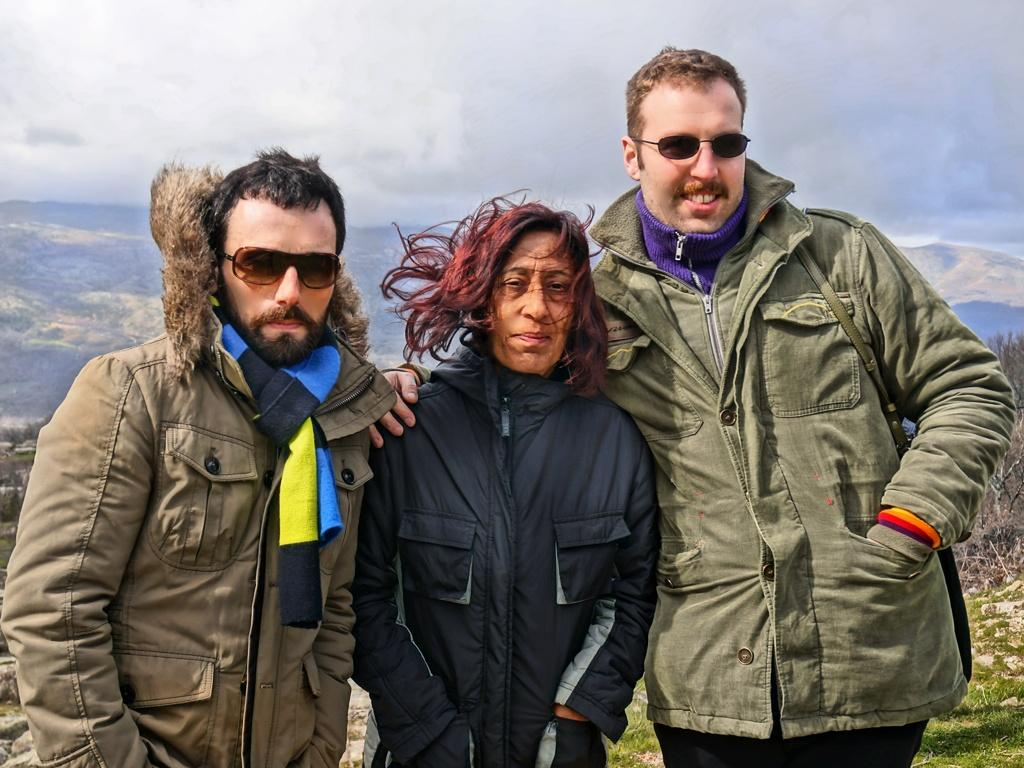How many people are present in the image? There are three people standing in the image. What can be seen behind the people? There are trees visible behind the people. What other features can be seen in the background? There are hills visible in the background. What is visible at the top of the image? The sky is visible in the image. Can you tell me how many boats are docked at the harbor in the image? There is no harbor or boats present in the image; it features three people standing in front of trees and hills. What type of branch is being used by the person on the left in the image? There is no branch visible in the image; it only shows three people standing in front of trees and hills. 